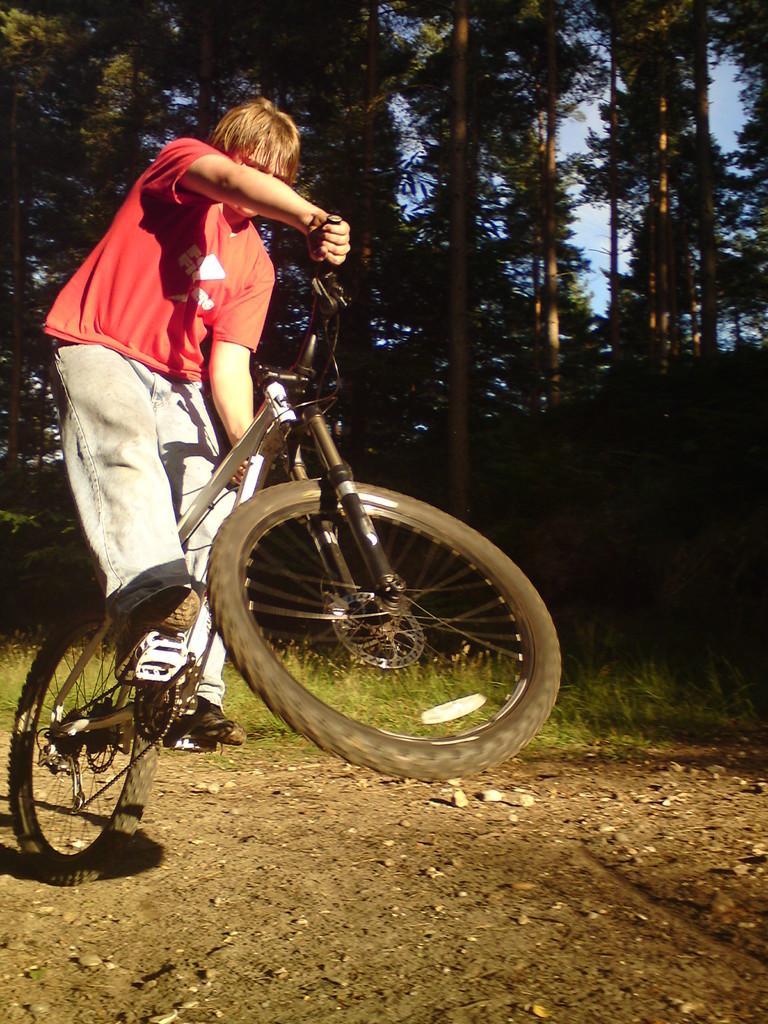Please provide a concise description of this image. On the left a man is riding bicycle he wear red t shirt ,trouser and shoes. In the background there are trees ,grass. At the bottom there are stones and land. 